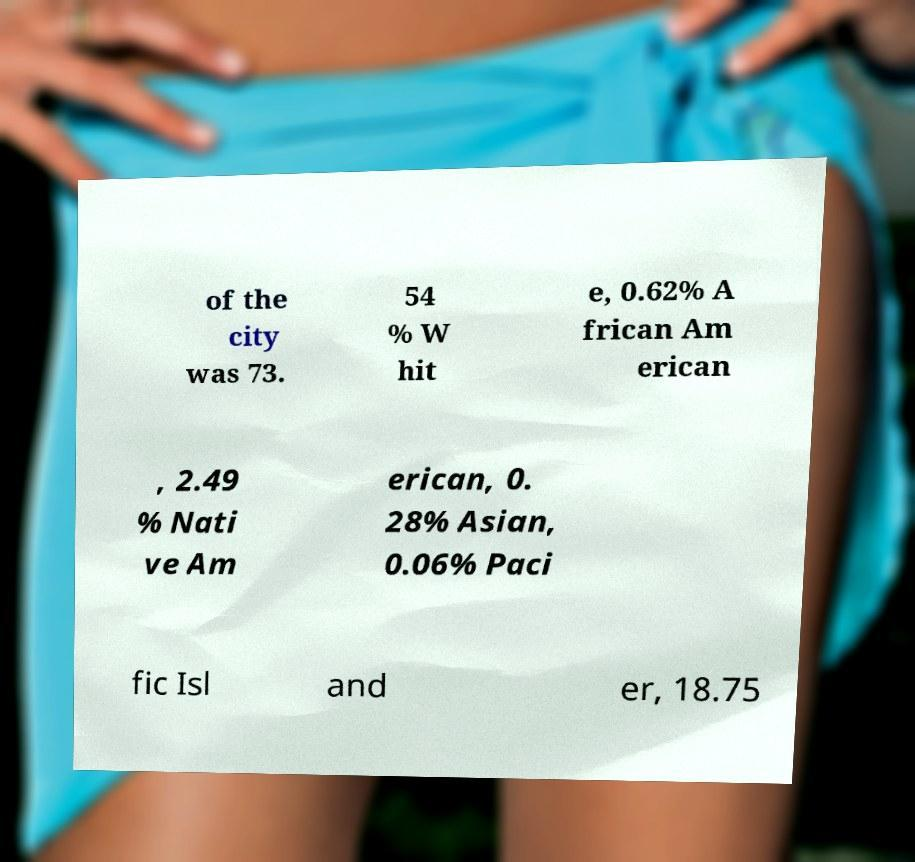For documentation purposes, I need the text within this image transcribed. Could you provide that? of the city was 73. 54 % W hit e, 0.62% A frican Am erican , 2.49 % Nati ve Am erican, 0. 28% Asian, 0.06% Paci fic Isl and er, 18.75 